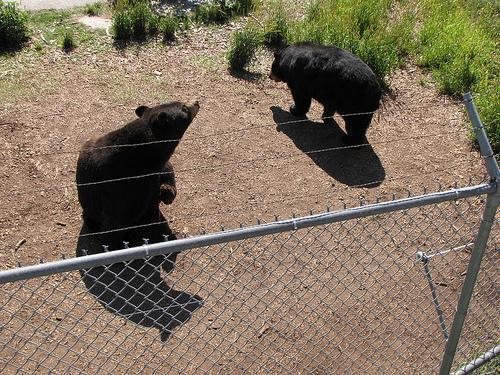How many bears are in the photo?
Give a very brief answer. 2. 